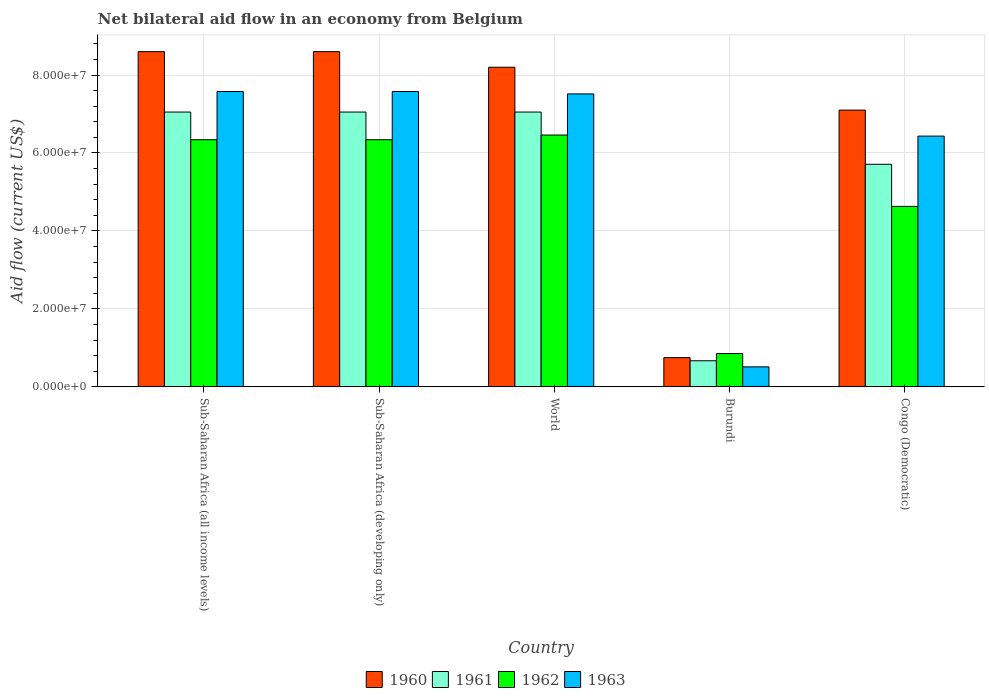How many different coloured bars are there?
Make the answer very short. 4. Are the number of bars per tick equal to the number of legend labels?
Offer a terse response. Yes. How many bars are there on the 5th tick from the left?
Offer a very short reply. 4. How many bars are there on the 2nd tick from the right?
Your response must be concise. 4. What is the label of the 2nd group of bars from the left?
Your answer should be compact. Sub-Saharan Africa (developing only). In how many cases, is the number of bars for a given country not equal to the number of legend labels?
Provide a succinct answer. 0. What is the net bilateral aid flow in 1960 in Burundi?
Offer a very short reply. 7.50e+06. Across all countries, what is the maximum net bilateral aid flow in 1960?
Your response must be concise. 8.60e+07. Across all countries, what is the minimum net bilateral aid flow in 1962?
Offer a terse response. 8.55e+06. In which country was the net bilateral aid flow in 1960 maximum?
Make the answer very short. Sub-Saharan Africa (all income levels). In which country was the net bilateral aid flow in 1962 minimum?
Offer a terse response. Burundi. What is the total net bilateral aid flow in 1963 in the graph?
Your answer should be very brief. 2.96e+08. What is the difference between the net bilateral aid flow in 1961 in Burundi and that in Sub-Saharan Africa (developing only)?
Provide a succinct answer. -6.38e+07. What is the difference between the net bilateral aid flow in 1960 in Sub-Saharan Africa (developing only) and the net bilateral aid flow in 1961 in Sub-Saharan Africa (all income levels)?
Give a very brief answer. 1.55e+07. What is the average net bilateral aid flow in 1960 per country?
Your answer should be very brief. 6.65e+07. What is the difference between the net bilateral aid flow of/in 1961 and net bilateral aid flow of/in 1960 in Burundi?
Your answer should be compact. -8.00e+05. In how many countries, is the net bilateral aid flow in 1961 greater than 32000000 US$?
Offer a very short reply. 4. What is the ratio of the net bilateral aid flow in 1961 in Congo (Democratic) to that in World?
Your response must be concise. 0.81. Is the difference between the net bilateral aid flow in 1961 in Burundi and Congo (Democratic) greater than the difference between the net bilateral aid flow in 1960 in Burundi and Congo (Democratic)?
Keep it short and to the point. Yes. What is the difference between the highest and the second highest net bilateral aid flow in 1962?
Provide a short and direct response. 1.21e+06. What is the difference between the highest and the lowest net bilateral aid flow in 1963?
Your response must be concise. 7.06e+07. In how many countries, is the net bilateral aid flow in 1962 greater than the average net bilateral aid flow in 1962 taken over all countries?
Your answer should be very brief. 3. Is the sum of the net bilateral aid flow in 1960 in Congo (Democratic) and Sub-Saharan Africa (all income levels) greater than the maximum net bilateral aid flow in 1961 across all countries?
Offer a terse response. Yes. Is it the case that in every country, the sum of the net bilateral aid flow in 1960 and net bilateral aid flow in 1962 is greater than the sum of net bilateral aid flow in 1961 and net bilateral aid flow in 1963?
Make the answer very short. No. What does the 1st bar from the left in Sub-Saharan Africa (all income levels) represents?
Provide a short and direct response. 1960. What does the 3rd bar from the right in World represents?
Your answer should be very brief. 1961. Is it the case that in every country, the sum of the net bilateral aid flow in 1961 and net bilateral aid flow in 1962 is greater than the net bilateral aid flow in 1963?
Your answer should be very brief. Yes. How many bars are there?
Ensure brevity in your answer.  20. Are all the bars in the graph horizontal?
Ensure brevity in your answer.  No. Are the values on the major ticks of Y-axis written in scientific E-notation?
Your response must be concise. Yes. Does the graph contain grids?
Your answer should be very brief. Yes. Where does the legend appear in the graph?
Provide a succinct answer. Bottom center. How many legend labels are there?
Offer a terse response. 4. How are the legend labels stacked?
Your answer should be very brief. Horizontal. What is the title of the graph?
Keep it short and to the point. Net bilateral aid flow in an economy from Belgium. What is the label or title of the Y-axis?
Keep it short and to the point. Aid flow (current US$). What is the Aid flow (current US$) of 1960 in Sub-Saharan Africa (all income levels)?
Provide a short and direct response. 8.60e+07. What is the Aid flow (current US$) of 1961 in Sub-Saharan Africa (all income levels)?
Provide a succinct answer. 7.05e+07. What is the Aid flow (current US$) in 1962 in Sub-Saharan Africa (all income levels)?
Offer a terse response. 6.34e+07. What is the Aid flow (current US$) in 1963 in Sub-Saharan Africa (all income levels)?
Offer a very short reply. 7.58e+07. What is the Aid flow (current US$) in 1960 in Sub-Saharan Africa (developing only)?
Provide a succinct answer. 8.60e+07. What is the Aid flow (current US$) of 1961 in Sub-Saharan Africa (developing only)?
Make the answer very short. 7.05e+07. What is the Aid flow (current US$) of 1962 in Sub-Saharan Africa (developing only)?
Provide a short and direct response. 6.34e+07. What is the Aid flow (current US$) in 1963 in Sub-Saharan Africa (developing only)?
Ensure brevity in your answer.  7.58e+07. What is the Aid flow (current US$) in 1960 in World?
Keep it short and to the point. 8.20e+07. What is the Aid flow (current US$) of 1961 in World?
Make the answer very short. 7.05e+07. What is the Aid flow (current US$) of 1962 in World?
Keep it short and to the point. 6.46e+07. What is the Aid flow (current US$) in 1963 in World?
Your answer should be compact. 7.52e+07. What is the Aid flow (current US$) in 1960 in Burundi?
Your response must be concise. 7.50e+06. What is the Aid flow (current US$) in 1961 in Burundi?
Ensure brevity in your answer.  6.70e+06. What is the Aid flow (current US$) of 1962 in Burundi?
Ensure brevity in your answer.  8.55e+06. What is the Aid flow (current US$) in 1963 in Burundi?
Offer a terse response. 5.13e+06. What is the Aid flow (current US$) in 1960 in Congo (Democratic)?
Your answer should be very brief. 7.10e+07. What is the Aid flow (current US$) in 1961 in Congo (Democratic)?
Your answer should be very brief. 5.71e+07. What is the Aid flow (current US$) in 1962 in Congo (Democratic)?
Offer a terse response. 4.63e+07. What is the Aid flow (current US$) of 1963 in Congo (Democratic)?
Your response must be concise. 6.43e+07. Across all countries, what is the maximum Aid flow (current US$) in 1960?
Make the answer very short. 8.60e+07. Across all countries, what is the maximum Aid flow (current US$) of 1961?
Offer a very short reply. 7.05e+07. Across all countries, what is the maximum Aid flow (current US$) of 1962?
Your answer should be very brief. 6.46e+07. Across all countries, what is the maximum Aid flow (current US$) of 1963?
Your response must be concise. 7.58e+07. Across all countries, what is the minimum Aid flow (current US$) in 1960?
Your answer should be very brief. 7.50e+06. Across all countries, what is the minimum Aid flow (current US$) of 1961?
Provide a succinct answer. 6.70e+06. Across all countries, what is the minimum Aid flow (current US$) of 1962?
Provide a short and direct response. 8.55e+06. Across all countries, what is the minimum Aid flow (current US$) of 1963?
Make the answer very short. 5.13e+06. What is the total Aid flow (current US$) in 1960 in the graph?
Provide a short and direct response. 3.32e+08. What is the total Aid flow (current US$) of 1961 in the graph?
Provide a short and direct response. 2.75e+08. What is the total Aid flow (current US$) of 1962 in the graph?
Make the answer very short. 2.46e+08. What is the total Aid flow (current US$) in 1963 in the graph?
Provide a succinct answer. 2.96e+08. What is the difference between the Aid flow (current US$) in 1960 in Sub-Saharan Africa (all income levels) and that in Sub-Saharan Africa (developing only)?
Give a very brief answer. 0. What is the difference between the Aid flow (current US$) of 1961 in Sub-Saharan Africa (all income levels) and that in Sub-Saharan Africa (developing only)?
Give a very brief answer. 0. What is the difference between the Aid flow (current US$) in 1961 in Sub-Saharan Africa (all income levels) and that in World?
Offer a terse response. 0. What is the difference between the Aid flow (current US$) in 1962 in Sub-Saharan Africa (all income levels) and that in World?
Your response must be concise. -1.21e+06. What is the difference between the Aid flow (current US$) in 1960 in Sub-Saharan Africa (all income levels) and that in Burundi?
Give a very brief answer. 7.85e+07. What is the difference between the Aid flow (current US$) in 1961 in Sub-Saharan Africa (all income levels) and that in Burundi?
Your answer should be very brief. 6.38e+07. What is the difference between the Aid flow (current US$) of 1962 in Sub-Saharan Africa (all income levels) and that in Burundi?
Offer a terse response. 5.48e+07. What is the difference between the Aid flow (current US$) in 1963 in Sub-Saharan Africa (all income levels) and that in Burundi?
Offer a very short reply. 7.06e+07. What is the difference between the Aid flow (current US$) in 1960 in Sub-Saharan Africa (all income levels) and that in Congo (Democratic)?
Offer a terse response. 1.50e+07. What is the difference between the Aid flow (current US$) of 1961 in Sub-Saharan Africa (all income levels) and that in Congo (Democratic)?
Your response must be concise. 1.34e+07. What is the difference between the Aid flow (current US$) in 1962 in Sub-Saharan Africa (all income levels) and that in Congo (Democratic)?
Provide a short and direct response. 1.71e+07. What is the difference between the Aid flow (current US$) in 1963 in Sub-Saharan Africa (all income levels) and that in Congo (Democratic)?
Offer a very short reply. 1.14e+07. What is the difference between the Aid flow (current US$) in 1960 in Sub-Saharan Africa (developing only) and that in World?
Your answer should be very brief. 4.00e+06. What is the difference between the Aid flow (current US$) of 1962 in Sub-Saharan Africa (developing only) and that in World?
Ensure brevity in your answer.  -1.21e+06. What is the difference between the Aid flow (current US$) of 1960 in Sub-Saharan Africa (developing only) and that in Burundi?
Make the answer very short. 7.85e+07. What is the difference between the Aid flow (current US$) of 1961 in Sub-Saharan Africa (developing only) and that in Burundi?
Your answer should be compact. 6.38e+07. What is the difference between the Aid flow (current US$) of 1962 in Sub-Saharan Africa (developing only) and that in Burundi?
Offer a very short reply. 5.48e+07. What is the difference between the Aid flow (current US$) in 1963 in Sub-Saharan Africa (developing only) and that in Burundi?
Offer a terse response. 7.06e+07. What is the difference between the Aid flow (current US$) in 1960 in Sub-Saharan Africa (developing only) and that in Congo (Democratic)?
Give a very brief answer. 1.50e+07. What is the difference between the Aid flow (current US$) of 1961 in Sub-Saharan Africa (developing only) and that in Congo (Democratic)?
Your answer should be compact. 1.34e+07. What is the difference between the Aid flow (current US$) of 1962 in Sub-Saharan Africa (developing only) and that in Congo (Democratic)?
Your answer should be compact. 1.71e+07. What is the difference between the Aid flow (current US$) in 1963 in Sub-Saharan Africa (developing only) and that in Congo (Democratic)?
Offer a very short reply. 1.14e+07. What is the difference between the Aid flow (current US$) in 1960 in World and that in Burundi?
Provide a short and direct response. 7.45e+07. What is the difference between the Aid flow (current US$) of 1961 in World and that in Burundi?
Provide a short and direct response. 6.38e+07. What is the difference between the Aid flow (current US$) of 1962 in World and that in Burundi?
Your answer should be compact. 5.61e+07. What is the difference between the Aid flow (current US$) in 1963 in World and that in Burundi?
Your response must be concise. 7.00e+07. What is the difference between the Aid flow (current US$) of 1960 in World and that in Congo (Democratic)?
Your answer should be very brief. 1.10e+07. What is the difference between the Aid flow (current US$) in 1961 in World and that in Congo (Democratic)?
Keep it short and to the point. 1.34e+07. What is the difference between the Aid flow (current US$) in 1962 in World and that in Congo (Democratic)?
Provide a succinct answer. 1.83e+07. What is the difference between the Aid flow (current US$) of 1963 in World and that in Congo (Democratic)?
Make the answer very short. 1.08e+07. What is the difference between the Aid flow (current US$) in 1960 in Burundi and that in Congo (Democratic)?
Your answer should be very brief. -6.35e+07. What is the difference between the Aid flow (current US$) of 1961 in Burundi and that in Congo (Democratic)?
Your answer should be compact. -5.04e+07. What is the difference between the Aid flow (current US$) of 1962 in Burundi and that in Congo (Democratic)?
Ensure brevity in your answer.  -3.78e+07. What is the difference between the Aid flow (current US$) in 1963 in Burundi and that in Congo (Democratic)?
Provide a succinct answer. -5.92e+07. What is the difference between the Aid flow (current US$) of 1960 in Sub-Saharan Africa (all income levels) and the Aid flow (current US$) of 1961 in Sub-Saharan Africa (developing only)?
Give a very brief answer. 1.55e+07. What is the difference between the Aid flow (current US$) of 1960 in Sub-Saharan Africa (all income levels) and the Aid flow (current US$) of 1962 in Sub-Saharan Africa (developing only)?
Your answer should be very brief. 2.26e+07. What is the difference between the Aid flow (current US$) of 1960 in Sub-Saharan Africa (all income levels) and the Aid flow (current US$) of 1963 in Sub-Saharan Africa (developing only)?
Keep it short and to the point. 1.02e+07. What is the difference between the Aid flow (current US$) of 1961 in Sub-Saharan Africa (all income levels) and the Aid flow (current US$) of 1962 in Sub-Saharan Africa (developing only)?
Your answer should be very brief. 7.10e+06. What is the difference between the Aid flow (current US$) of 1961 in Sub-Saharan Africa (all income levels) and the Aid flow (current US$) of 1963 in Sub-Saharan Africa (developing only)?
Provide a succinct answer. -5.27e+06. What is the difference between the Aid flow (current US$) of 1962 in Sub-Saharan Africa (all income levels) and the Aid flow (current US$) of 1963 in Sub-Saharan Africa (developing only)?
Your answer should be compact. -1.24e+07. What is the difference between the Aid flow (current US$) of 1960 in Sub-Saharan Africa (all income levels) and the Aid flow (current US$) of 1961 in World?
Your answer should be very brief. 1.55e+07. What is the difference between the Aid flow (current US$) in 1960 in Sub-Saharan Africa (all income levels) and the Aid flow (current US$) in 1962 in World?
Your response must be concise. 2.14e+07. What is the difference between the Aid flow (current US$) in 1960 in Sub-Saharan Africa (all income levels) and the Aid flow (current US$) in 1963 in World?
Ensure brevity in your answer.  1.08e+07. What is the difference between the Aid flow (current US$) in 1961 in Sub-Saharan Africa (all income levels) and the Aid flow (current US$) in 1962 in World?
Offer a very short reply. 5.89e+06. What is the difference between the Aid flow (current US$) of 1961 in Sub-Saharan Africa (all income levels) and the Aid flow (current US$) of 1963 in World?
Your answer should be compact. -4.66e+06. What is the difference between the Aid flow (current US$) of 1962 in Sub-Saharan Africa (all income levels) and the Aid flow (current US$) of 1963 in World?
Make the answer very short. -1.18e+07. What is the difference between the Aid flow (current US$) of 1960 in Sub-Saharan Africa (all income levels) and the Aid flow (current US$) of 1961 in Burundi?
Your answer should be compact. 7.93e+07. What is the difference between the Aid flow (current US$) of 1960 in Sub-Saharan Africa (all income levels) and the Aid flow (current US$) of 1962 in Burundi?
Provide a short and direct response. 7.74e+07. What is the difference between the Aid flow (current US$) of 1960 in Sub-Saharan Africa (all income levels) and the Aid flow (current US$) of 1963 in Burundi?
Ensure brevity in your answer.  8.09e+07. What is the difference between the Aid flow (current US$) in 1961 in Sub-Saharan Africa (all income levels) and the Aid flow (current US$) in 1962 in Burundi?
Ensure brevity in your answer.  6.20e+07. What is the difference between the Aid flow (current US$) of 1961 in Sub-Saharan Africa (all income levels) and the Aid flow (current US$) of 1963 in Burundi?
Provide a short and direct response. 6.54e+07. What is the difference between the Aid flow (current US$) in 1962 in Sub-Saharan Africa (all income levels) and the Aid flow (current US$) in 1963 in Burundi?
Offer a terse response. 5.83e+07. What is the difference between the Aid flow (current US$) in 1960 in Sub-Saharan Africa (all income levels) and the Aid flow (current US$) in 1961 in Congo (Democratic)?
Your answer should be very brief. 2.89e+07. What is the difference between the Aid flow (current US$) in 1960 in Sub-Saharan Africa (all income levels) and the Aid flow (current US$) in 1962 in Congo (Democratic)?
Keep it short and to the point. 3.97e+07. What is the difference between the Aid flow (current US$) of 1960 in Sub-Saharan Africa (all income levels) and the Aid flow (current US$) of 1963 in Congo (Democratic)?
Keep it short and to the point. 2.17e+07. What is the difference between the Aid flow (current US$) of 1961 in Sub-Saharan Africa (all income levels) and the Aid flow (current US$) of 1962 in Congo (Democratic)?
Make the answer very short. 2.42e+07. What is the difference between the Aid flow (current US$) in 1961 in Sub-Saharan Africa (all income levels) and the Aid flow (current US$) in 1963 in Congo (Democratic)?
Offer a terse response. 6.17e+06. What is the difference between the Aid flow (current US$) of 1962 in Sub-Saharan Africa (all income levels) and the Aid flow (current US$) of 1963 in Congo (Democratic)?
Offer a terse response. -9.30e+05. What is the difference between the Aid flow (current US$) of 1960 in Sub-Saharan Africa (developing only) and the Aid flow (current US$) of 1961 in World?
Your answer should be compact. 1.55e+07. What is the difference between the Aid flow (current US$) in 1960 in Sub-Saharan Africa (developing only) and the Aid flow (current US$) in 1962 in World?
Ensure brevity in your answer.  2.14e+07. What is the difference between the Aid flow (current US$) in 1960 in Sub-Saharan Africa (developing only) and the Aid flow (current US$) in 1963 in World?
Offer a terse response. 1.08e+07. What is the difference between the Aid flow (current US$) in 1961 in Sub-Saharan Africa (developing only) and the Aid flow (current US$) in 1962 in World?
Your answer should be compact. 5.89e+06. What is the difference between the Aid flow (current US$) in 1961 in Sub-Saharan Africa (developing only) and the Aid flow (current US$) in 1963 in World?
Ensure brevity in your answer.  -4.66e+06. What is the difference between the Aid flow (current US$) in 1962 in Sub-Saharan Africa (developing only) and the Aid flow (current US$) in 1963 in World?
Give a very brief answer. -1.18e+07. What is the difference between the Aid flow (current US$) in 1960 in Sub-Saharan Africa (developing only) and the Aid flow (current US$) in 1961 in Burundi?
Make the answer very short. 7.93e+07. What is the difference between the Aid flow (current US$) in 1960 in Sub-Saharan Africa (developing only) and the Aid flow (current US$) in 1962 in Burundi?
Your answer should be compact. 7.74e+07. What is the difference between the Aid flow (current US$) in 1960 in Sub-Saharan Africa (developing only) and the Aid flow (current US$) in 1963 in Burundi?
Your answer should be very brief. 8.09e+07. What is the difference between the Aid flow (current US$) in 1961 in Sub-Saharan Africa (developing only) and the Aid flow (current US$) in 1962 in Burundi?
Provide a succinct answer. 6.20e+07. What is the difference between the Aid flow (current US$) of 1961 in Sub-Saharan Africa (developing only) and the Aid flow (current US$) of 1963 in Burundi?
Provide a short and direct response. 6.54e+07. What is the difference between the Aid flow (current US$) in 1962 in Sub-Saharan Africa (developing only) and the Aid flow (current US$) in 1963 in Burundi?
Your answer should be very brief. 5.83e+07. What is the difference between the Aid flow (current US$) of 1960 in Sub-Saharan Africa (developing only) and the Aid flow (current US$) of 1961 in Congo (Democratic)?
Offer a terse response. 2.89e+07. What is the difference between the Aid flow (current US$) in 1960 in Sub-Saharan Africa (developing only) and the Aid flow (current US$) in 1962 in Congo (Democratic)?
Offer a terse response. 3.97e+07. What is the difference between the Aid flow (current US$) in 1960 in Sub-Saharan Africa (developing only) and the Aid flow (current US$) in 1963 in Congo (Democratic)?
Keep it short and to the point. 2.17e+07. What is the difference between the Aid flow (current US$) in 1961 in Sub-Saharan Africa (developing only) and the Aid flow (current US$) in 1962 in Congo (Democratic)?
Make the answer very short. 2.42e+07. What is the difference between the Aid flow (current US$) of 1961 in Sub-Saharan Africa (developing only) and the Aid flow (current US$) of 1963 in Congo (Democratic)?
Provide a short and direct response. 6.17e+06. What is the difference between the Aid flow (current US$) in 1962 in Sub-Saharan Africa (developing only) and the Aid flow (current US$) in 1963 in Congo (Democratic)?
Offer a very short reply. -9.30e+05. What is the difference between the Aid flow (current US$) in 1960 in World and the Aid flow (current US$) in 1961 in Burundi?
Give a very brief answer. 7.53e+07. What is the difference between the Aid flow (current US$) of 1960 in World and the Aid flow (current US$) of 1962 in Burundi?
Provide a succinct answer. 7.34e+07. What is the difference between the Aid flow (current US$) of 1960 in World and the Aid flow (current US$) of 1963 in Burundi?
Your answer should be compact. 7.69e+07. What is the difference between the Aid flow (current US$) of 1961 in World and the Aid flow (current US$) of 1962 in Burundi?
Offer a very short reply. 6.20e+07. What is the difference between the Aid flow (current US$) of 1961 in World and the Aid flow (current US$) of 1963 in Burundi?
Give a very brief answer. 6.54e+07. What is the difference between the Aid flow (current US$) of 1962 in World and the Aid flow (current US$) of 1963 in Burundi?
Your answer should be compact. 5.95e+07. What is the difference between the Aid flow (current US$) of 1960 in World and the Aid flow (current US$) of 1961 in Congo (Democratic)?
Give a very brief answer. 2.49e+07. What is the difference between the Aid flow (current US$) of 1960 in World and the Aid flow (current US$) of 1962 in Congo (Democratic)?
Your answer should be compact. 3.57e+07. What is the difference between the Aid flow (current US$) of 1960 in World and the Aid flow (current US$) of 1963 in Congo (Democratic)?
Provide a short and direct response. 1.77e+07. What is the difference between the Aid flow (current US$) in 1961 in World and the Aid flow (current US$) in 1962 in Congo (Democratic)?
Offer a terse response. 2.42e+07. What is the difference between the Aid flow (current US$) in 1961 in World and the Aid flow (current US$) in 1963 in Congo (Democratic)?
Offer a terse response. 6.17e+06. What is the difference between the Aid flow (current US$) in 1960 in Burundi and the Aid flow (current US$) in 1961 in Congo (Democratic)?
Your answer should be very brief. -4.96e+07. What is the difference between the Aid flow (current US$) of 1960 in Burundi and the Aid flow (current US$) of 1962 in Congo (Democratic)?
Your answer should be very brief. -3.88e+07. What is the difference between the Aid flow (current US$) in 1960 in Burundi and the Aid flow (current US$) in 1963 in Congo (Democratic)?
Keep it short and to the point. -5.68e+07. What is the difference between the Aid flow (current US$) of 1961 in Burundi and the Aid flow (current US$) of 1962 in Congo (Democratic)?
Your answer should be very brief. -3.96e+07. What is the difference between the Aid flow (current US$) in 1961 in Burundi and the Aid flow (current US$) in 1963 in Congo (Democratic)?
Your answer should be very brief. -5.76e+07. What is the difference between the Aid flow (current US$) of 1962 in Burundi and the Aid flow (current US$) of 1963 in Congo (Democratic)?
Your answer should be compact. -5.58e+07. What is the average Aid flow (current US$) of 1960 per country?
Provide a short and direct response. 6.65e+07. What is the average Aid flow (current US$) of 1961 per country?
Your answer should be very brief. 5.51e+07. What is the average Aid flow (current US$) of 1962 per country?
Make the answer very short. 4.93e+07. What is the average Aid flow (current US$) of 1963 per country?
Your response must be concise. 5.92e+07. What is the difference between the Aid flow (current US$) in 1960 and Aid flow (current US$) in 1961 in Sub-Saharan Africa (all income levels)?
Offer a very short reply. 1.55e+07. What is the difference between the Aid flow (current US$) in 1960 and Aid flow (current US$) in 1962 in Sub-Saharan Africa (all income levels)?
Keep it short and to the point. 2.26e+07. What is the difference between the Aid flow (current US$) of 1960 and Aid flow (current US$) of 1963 in Sub-Saharan Africa (all income levels)?
Offer a terse response. 1.02e+07. What is the difference between the Aid flow (current US$) in 1961 and Aid flow (current US$) in 1962 in Sub-Saharan Africa (all income levels)?
Offer a very short reply. 7.10e+06. What is the difference between the Aid flow (current US$) of 1961 and Aid flow (current US$) of 1963 in Sub-Saharan Africa (all income levels)?
Provide a short and direct response. -5.27e+06. What is the difference between the Aid flow (current US$) of 1962 and Aid flow (current US$) of 1963 in Sub-Saharan Africa (all income levels)?
Ensure brevity in your answer.  -1.24e+07. What is the difference between the Aid flow (current US$) of 1960 and Aid flow (current US$) of 1961 in Sub-Saharan Africa (developing only)?
Ensure brevity in your answer.  1.55e+07. What is the difference between the Aid flow (current US$) in 1960 and Aid flow (current US$) in 1962 in Sub-Saharan Africa (developing only)?
Keep it short and to the point. 2.26e+07. What is the difference between the Aid flow (current US$) of 1960 and Aid flow (current US$) of 1963 in Sub-Saharan Africa (developing only)?
Offer a terse response. 1.02e+07. What is the difference between the Aid flow (current US$) in 1961 and Aid flow (current US$) in 1962 in Sub-Saharan Africa (developing only)?
Ensure brevity in your answer.  7.10e+06. What is the difference between the Aid flow (current US$) in 1961 and Aid flow (current US$) in 1963 in Sub-Saharan Africa (developing only)?
Provide a succinct answer. -5.27e+06. What is the difference between the Aid flow (current US$) in 1962 and Aid flow (current US$) in 1963 in Sub-Saharan Africa (developing only)?
Your answer should be compact. -1.24e+07. What is the difference between the Aid flow (current US$) of 1960 and Aid flow (current US$) of 1961 in World?
Your response must be concise. 1.15e+07. What is the difference between the Aid flow (current US$) in 1960 and Aid flow (current US$) in 1962 in World?
Give a very brief answer. 1.74e+07. What is the difference between the Aid flow (current US$) in 1960 and Aid flow (current US$) in 1963 in World?
Provide a succinct answer. 6.84e+06. What is the difference between the Aid flow (current US$) in 1961 and Aid flow (current US$) in 1962 in World?
Your answer should be compact. 5.89e+06. What is the difference between the Aid flow (current US$) in 1961 and Aid flow (current US$) in 1963 in World?
Provide a short and direct response. -4.66e+06. What is the difference between the Aid flow (current US$) of 1962 and Aid flow (current US$) of 1963 in World?
Your answer should be compact. -1.06e+07. What is the difference between the Aid flow (current US$) in 1960 and Aid flow (current US$) in 1961 in Burundi?
Provide a short and direct response. 8.00e+05. What is the difference between the Aid flow (current US$) in 1960 and Aid flow (current US$) in 1962 in Burundi?
Your response must be concise. -1.05e+06. What is the difference between the Aid flow (current US$) in 1960 and Aid flow (current US$) in 1963 in Burundi?
Offer a very short reply. 2.37e+06. What is the difference between the Aid flow (current US$) in 1961 and Aid flow (current US$) in 1962 in Burundi?
Ensure brevity in your answer.  -1.85e+06. What is the difference between the Aid flow (current US$) in 1961 and Aid flow (current US$) in 1963 in Burundi?
Keep it short and to the point. 1.57e+06. What is the difference between the Aid flow (current US$) in 1962 and Aid flow (current US$) in 1963 in Burundi?
Offer a very short reply. 3.42e+06. What is the difference between the Aid flow (current US$) in 1960 and Aid flow (current US$) in 1961 in Congo (Democratic)?
Make the answer very short. 1.39e+07. What is the difference between the Aid flow (current US$) of 1960 and Aid flow (current US$) of 1962 in Congo (Democratic)?
Give a very brief answer. 2.47e+07. What is the difference between the Aid flow (current US$) in 1960 and Aid flow (current US$) in 1963 in Congo (Democratic)?
Make the answer very short. 6.67e+06. What is the difference between the Aid flow (current US$) in 1961 and Aid flow (current US$) in 1962 in Congo (Democratic)?
Your response must be concise. 1.08e+07. What is the difference between the Aid flow (current US$) in 1961 and Aid flow (current US$) in 1963 in Congo (Democratic)?
Provide a short and direct response. -7.23e+06. What is the difference between the Aid flow (current US$) in 1962 and Aid flow (current US$) in 1963 in Congo (Democratic)?
Keep it short and to the point. -1.80e+07. What is the ratio of the Aid flow (current US$) in 1960 in Sub-Saharan Africa (all income levels) to that in World?
Offer a terse response. 1.05. What is the ratio of the Aid flow (current US$) of 1961 in Sub-Saharan Africa (all income levels) to that in World?
Offer a very short reply. 1. What is the ratio of the Aid flow (current US$) in 1962 in Sub-Saharan Africa (all income levels) to that in World?
Provide a succinct answer. 0.98. What is the ratio of the Aid flow (current US$) of 1960 in Sub-Saharan Africa (all income levels) to that in Burundi?
Give a very brief answer. 11.47. What is the ratio of the Aid flow (current US$) of 1961 in Sub-Saharan Africa (all income levels) to that in Burundi?
Keep it short and to the point. 10.52. What is the ratio of the Aid flow (current US$) of 1962 in Sub-Saharan Africa (all income levels) to that in Burundi?
Ensure brevity in your answer.  7.42. What is the ratio of the Aid flow (current US$) in 1963 in Sub-Saharan Africa (all income levels) to that in Burundi?
Ensure brevity in your answer.  14.77. What is the ratio of the Aid flow (current US$) of 1960 in Sub-Saharan Africa (all income levels) to that in Congo (Democratic)?
Provide a succinct answer. 1.21. What is the ratio of the Aid flow (current US$) of 1961 in Sub-Saharan Africa (all income levels) to that in Congo (Democratic)?
Offer a terse response. 1.23. What is the ratio of the Aid flow (current US$) in 1962 in Sub-Saharan Africa (all income levels) to that in Congo (Democratic)?
Your answer should be very brief. 1.37. What is the ratio of the Aid flow (current US$) in 1963 in Sub-Saharan Africa (all income levels) to that in Congo (Democratic)?
Give a very brief answer. 1.18. What is the ratio of the Aid flow (current US$) in 1960 in Sub-Saharan Africa (developing only) to that in World?
Provide a short and direct response. 1.05. What is the ratio of the Aid flow (current US$) of 1962 in Sub-Saharan Africa (developing only) to that in World?
Ensure brevity in your answer.  0.98. What is the ratio of the Aid flow (current US$) of 1963 in Sub-Saharan Africa (developing only) to that in World?
Give a very brief answer. 1.01. What is the ratio of the Aid flow (current US$) of 1960 in Sub-Saharan Africa (developing only) to that in Burundi?
Your response must be concise. 11.47. What is the ratio of the Aid flow (current US$) in 1961 in Sub-Saharan Africa (developing only) to that in Burundi?
Ensure brevity in your answer.  10.52. What is the ratio of the Aid flow (current US$) in 1962 in Sub-Saharan Africa (developing only) to that in Burundi?
Provide a short and direct response. 7.42. What is the ratio of the Aid flow (current US$) of 1963 in Sub-Saharan Africa (developing only) to that in Burundi?
Make the answer very short. 14.77. What is the ratio of the Aid flow (current US$) of 1960 in Sub-Saharan Africa (developing only) to that in Congo (Democratic)?
Offer a terse response. 1.21. What is the ratio of the Aid flow (current US$) of 1961 in Sub-Saharan Africa (developing only) to that in Congo (Democratic)?
Provide a short and direct response. 1.23. What is the ratio of the Aid flow (current US$) in 1962 in Sub-Saharan Africa (developing only) to that in Congo (Democratic)?
Give a very brief answer. 1.37. What is the ratio of the Aid flow (current US$) in 1963 in Sub-Saharan Africa (developing only) to that in Congo (Democratic)?
Your answer should be very brief. 1.18. What is the ratio of the Aid flow (current US$) of 1960 in World to that in Burundi?
Give a very brief answer. 10.93. What is the ratio of the Aid flow (current US$) in 1961 in World to that in Burundi?
Keep it short and to the point. 10.52. What is the ratio of the Aid flow (current US$) of 1962 in World to that in Burundi?
Give a very brief answer. 7.56. What is the ratio of the Aid flow (current US$) in 1963 in World to that in Burundi?
Your answer should be compact. 14.65. What is the ratio of the Aid flow (current US$) of 1960 in World to that in Congo (Democratic)?
Provide a succinct answer. 1.15. What is the ratio of the Aid flow (current US$) in 1961 in World to that in Congo (Democratic)?
Give a very brief answer. 1.23. What is the ratio of the Aid flow (current US$) in 1962 in World to that in Congo (Democratic)?
Give a very brief answer. 1.4. What is the ratio of the Aid flow (current US$) in 1963 in World to that in Congo (Democratic)?
Make the answer very short. 1.17. What is the ratio of the Aid flow (current US$) of 1960 in Burundi to that in Congo (Democratic)?
Give a very brief answer. 0.11. What is the ratio of the Aid flow (current US$) in 1961 in Burundi to that in Congo (Democratic)?
Ensure brevity in your answer.  0.12. What is the ratio of the Aid flow (current US$) of 1962 in Burundi to that in Congo (Democratic)?
Your answer should be compact. 0.18. What is the ratio of the Aid flow (current US$) in 1963 in Burundi to that in Congo (Democratic)?
Your answer should be compact. 0.08. What is the difference between the highest and the second highest Aid flow (current US$) of 1960?
Offer a terse response. 0. What is the difference between the highest and the second highest Aid flow (current US$) of 1962?
Make the answer very short. 1.21e+06. What is the difference between the highest and the lowest Aid flow (current US$) of 1960?
Offer a very short reply. 7.85e+07. What is the difference between the highest and the lowest Aid flow (current US$) in 1961?
Provide a short and direct response. 6.38e+07. What is the difference between the highest and the lowest Aid flow (current US$) in 1962?
Make the answer very short. 5.61e+07. What is the difference between the highest and the lowest Aid flow (current US$) of 1963?
Ensure brevity in your answer.  7.06e+07. 